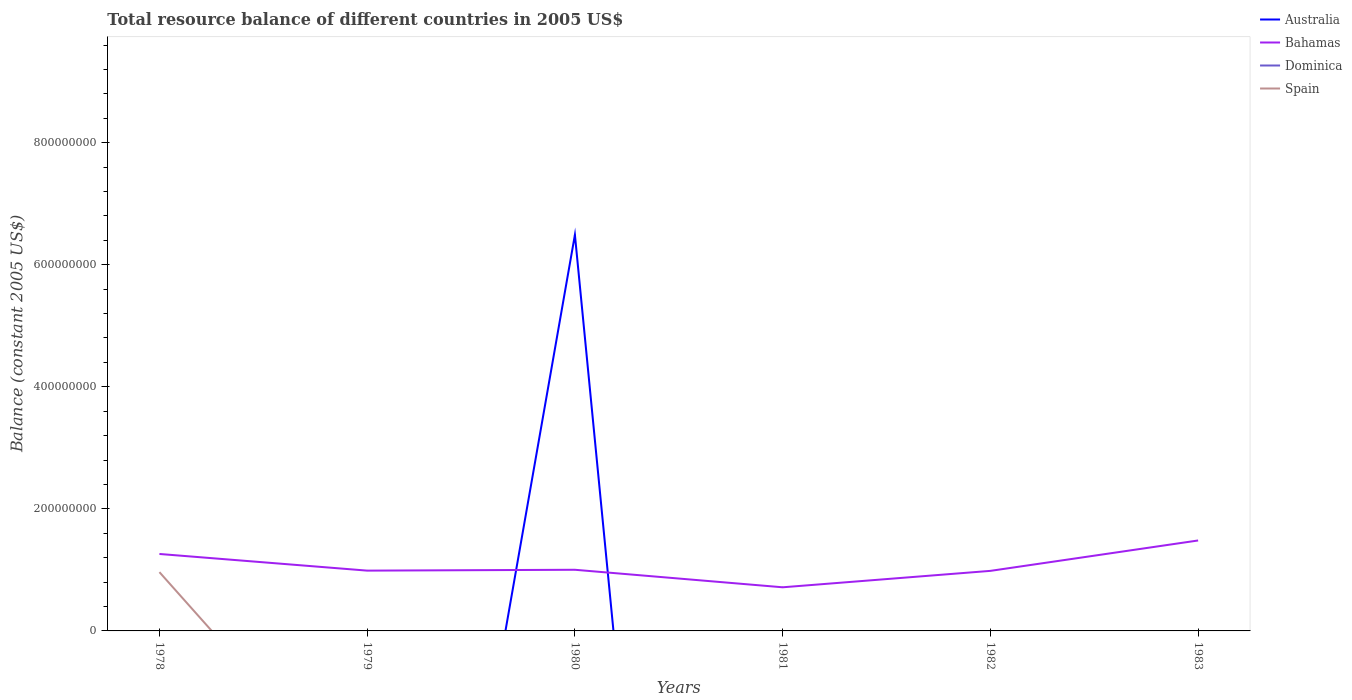How many different coloured lines are there?
Give a very brief answer. 3. Does the line corresponding to Australia intersect with the line corresponding to Dominica?
Offer a terse response. Yes. Is the number of lines equal to the number of legend labels?
Your answer should be very brief. No. Across all years, what is the maximum total resource balance in Bahamas?
Provide a short and direct response. 7.15e+07. What is the difference between the highest and the second highest total resource balance in Spain?
Make the answer very short. 9.63e+07. What is the difference between the highest and the lowest total resource balance in Dominica?
Offer a very short reply. 0. How many years are there in the graph?
Your answer should be compact. 6. What is the difference between two consecutive major ticks on the Y-axis?
Give a very brief answer. 2.00e+08. Does the graph contain any zero values?
Ensure brevity in your answer.  Yes. Does the graph contain grids?
Provide a short and direct response. No. How many legend labels are there?
Provide a short and direct response. 4. What is the title of the graph?
Your answer should be compact. Total resource balance of different countries in 2005 US$. What is the label or title of the X-axis?
Provide a succinct answer. Years. What is the label or title of the Y-axis?
Give a very brief answer. Balance (constant 2005 US$). What is the Balance (constant 2005 US$) of Australia in 1978?
Give a very brief answer. 0. What is the Balance (constant 2005 US$) of Bahamas in 1978?
Your response must be concise. 1.26e+08. What is the Balance (constant 2005 US$) of Spain in 1978?
Keep it short and to the point. 9.63e+07. What is the Balance (constant 2005 US$) of Australia in 1979?
Ensure brevity in your answer.  0. What is the Balance (constant 2005 US$) in Bahamas in 1979?
Provide a succinct answer. 9.88e+07. What is the Balance (constant 2005 US$) of Spain in 1979?
Offer a terse response. 0. What is the Balance (constant 2005 US$) in Australia in 1980?
Your response must be concise. 6.49e+08. What is the Balance (constant 2005 US$) of Bahamas in 1980?
Offer a very short reply. 1.00e+08. What is the Balance (constant 2005 US$) in Spain in 1980?
Offer a terse response. 0. What is the Balance (constant 2005 US$) in Bahamas in 1981?
Your answer should be compact. 7.15e+07. What is the Balance (constant 2005 US$) in Dominica in 1981?
Ensure brevity in your answer.  0. What is the Balance (constant 2005 US$) of Spain in 1981?
Offer a terse response. 0. What is the Balance (constant 2005 US$) in Australia in 1982?
Keep it short and to the point. 0. What is the Balance (constant 2005 US$) in Bahamas in 1982?
Make the answer very short. 9.84e+07. What is the Balance (constant 2005 US$) of Dominica in 1982?
Keep it short and to the point. 0. What is the Balance (constant 2005 US$) of Spain in 1982?
Your answer should be compact. 0. What is the Balance (constant 2005 US$) in Australia in 1983?
Offer a terse response. 0. What is the Balance (constant 2005 US$) of Bahamas in 1983?
Give a very brief answer. 1.48e+08. What is the Balance (constant 2005 US$) of Dominica in 1983?
Give a very brief answer. 0. Across all years, what is the maximum Balance (constant 2005 US$) in Australia?
Make the answer very short. 6.49e+08. Across all years, what is the maximum Balance (constant 2005 US$) of Bahamas?
Your response must be concise. 1.48e+08. Across all years, what is the maximum Balance (constant 2005 US$) in Spain?
Offer a very short reply. 9.63e+07. Across all years, what is the minimum Balance (constant 2005 US$) in Australia?
Give a very brief answer. 0. Across all years, what is the minimum Balance (constant 2005 US$) of Bahamas?
Make the answer very short. 7.15e+07. What is the total Balance (constant 2005 US$) in Australia in the graph?
Your answer should be very brief. 6.49e+08. What is the total Balance (constant 2005 US$) in Bahamas in the graph?
Your answer should be very brief. 6.43e+08. What is the total Balance (constant 2005 US$) of Dominica in the graph?
Make the answer very short. 0. What is the total Balance (constant 2005 US$) in Spain in the graph?
Provide a succinct answer. 9.63e+07. What is the difference between the Balance (constant 2005 US$) of Bahamas in 1978 and that in 1979?
Offer a very short reply. 2.73e+07. What is the difference between the Balance (constant 2005 US$) in Bahamas in 1978 and that in 1980?
Provide a succinct answer. 2.59e+07. What is the difference between the Balance (constant 2005 US$) of Bahamas in 1978 and that in 1981?
Offer a very short reply. 5.46e+07. What is the difference between the Balance (constant 2005 US$) of Bahamas in 1978 and that in 1982?
Keep it short and to the point. 2.77e+07. What is the difference between the Balance (constant 2005 US$) in Bahamas in 1978 and that in 1983?
Make the answer very short. -2.21e+07. What is the difference between the Balance (constant 2005 US$) of Bahamas in 1979 and that in 1980?
Your answer should be compact. -1.40e+06. What is the difference between the Balance (constant 2005 US$) of Bahamas in 1979 and that in 1981?
Offer a terse response. 2.73e+07. What is the difference between the Balance (constant 2005 US$) in Bahamas in 1979 and that in 1983?
Offer a very short reply. -4.94e+07. What is the difference between the Balance (constant 2005 US$) of Bahamas in 1980 and that in 1981?
Provide a short and direct response. 2.87e+07. What is the difference between the Balance (constant 2005 US$) of Bahamas in 1980 and that in 1982?
Provide a short and direct response. 1.80e+06. What is the difference between the Balance (constant 2005 US$) of Bahamas in 1980 and that in 1983?
Your response must be concise. -4.80e+07. What is the difference between the Balance (constant 2005 US$) of Bahamas in 1981 and that in 1982?
Your answer should be very brief. -2.69e+07. What is the difference between the Balance (constant 2005 US$) of Bahamas in 1981 and that in 1983?
Your answer should be very brief. -7.67e+07. What is the difference between the Balance (constant 2005 US$) of Bahamas in 1982 and that in 1983?
Make the answer very short. -4.98e+07. What is the difference between the Balance (constant 2005 US$) of Australia in 1980 and the Balance (constant 2005 US$) of Bahamas in 1981?
Provide a short and direct response. 5.78e+08. What is the difference between the Balance (constant 2005 US$) in Australia in 1980 and the Balance (constant 2005 US$) in Bahamas in 1982?
Offer a very short reply. 5.51e+08. What is the difference between the Balance (constant 2005 US$) of Australia in 1980 and the Balance (constant 2005 US$) of Bahamas in 1983?
Keep it short and to the point. 5.01e+08. What is the average Balance (constant 2005 US$) of Australia per year?
Provide a short and direct response. 1.08e+08. What is the average Balance (constant 2005 US$) in Bahamas per year?
Your answer should be very brief. 1.07e+08. What is the average Balance (constant 2005 US$) of Dominica per year?
Your response must be concise. 0. What is the average Balance (constant 2005 US$) of Spain per year?
Your answer should be compact. 1.61e+07. In the year 1978, what is the difference between the Balance (constant 2005 US$) in Bahamas and Balance (constant 2005 US$) in Spain?
Provide a short and direct response. 2.98e+07. In the year 1980, what is the difference between the Balance (constant 2005 US$) of Australia and Balance (constant 2005 US$) of Bahamas?
Keep it short and to the point. 5.49e+08. What is the ratio of the Balance (constant 2005 US$) of Bahamas in 1978 to that in 1979?
Offer a very short reply. 1.28. What is the ratio of the Balance (constant 2005 US$) in Bahamas in 1978 to that in 1980?
Ensure brevity in your answer.  1.26. What is the ratio of the Balance (constant 2005 US$) in Bahamas in 1978 to that in 1981?
Provide a short and direct response. 1.76. What is the ratio of the Balance (constant 2005 US$) of Bahamas in 1978 to that in 1982?
Keep it short and to the point. 1.28. What is the ratio of the Balance (constant 2005 US$) in Bahamas in 1978 to that in 1983?
Keep it short and to the point. 0.85. What is the ratio of the Balance (constant 2005 US$) in Bahamas in 1979 to that in 1981?
Ensure brevity in your answer.  1.38. What is the ratio of the Balance (constant 2005 US$) of Bahamas in 1980 to that in 1981?
Offer a very short reply. 1.4. What is the ratio of the Balance (constant 2005 US$) of Bahamas in 1980 to that in 1982?
Offer a terse response. 1.02. What is the ratio of the Balance (constant 2005 US$) in Bahamas in 1980 to that in 1983?
Provide a succinct answer. 0.68. What is the ratio of the Balance (constant 2005 US$) of Bahamas in 1981 to that in 1982?
Your answer should be very brief. 0.73. What is the ratio of the Balance (constant 2005 US$) in Bahamas in 1981 to that in 1983?
Your answer should be compact. 0.48. What is the ratio of the Balance (constant 2005 US$) of Bahamas in 1982 to that in 1983?
Provide a short and direct response. 0.66. What is the difference between the highest and the second highest Balance (constant 2005 US$) in Bahamas?
Your answer should be compact. 2.21e+07. What is the difference between the highest and the lowest Balance (constant 2005 US$) in Australia?
Your answer should be compact. 6.49e+08. What is the difference between the highest and the lowest Balance (constant 2005 US$) in Bahamas?
Your response must be concise. 7.67e+07. What is the difference between the highest and the lowest Balance (constant 2005 US$) of Spain?
Offer a terse response. 9.63e+07. 